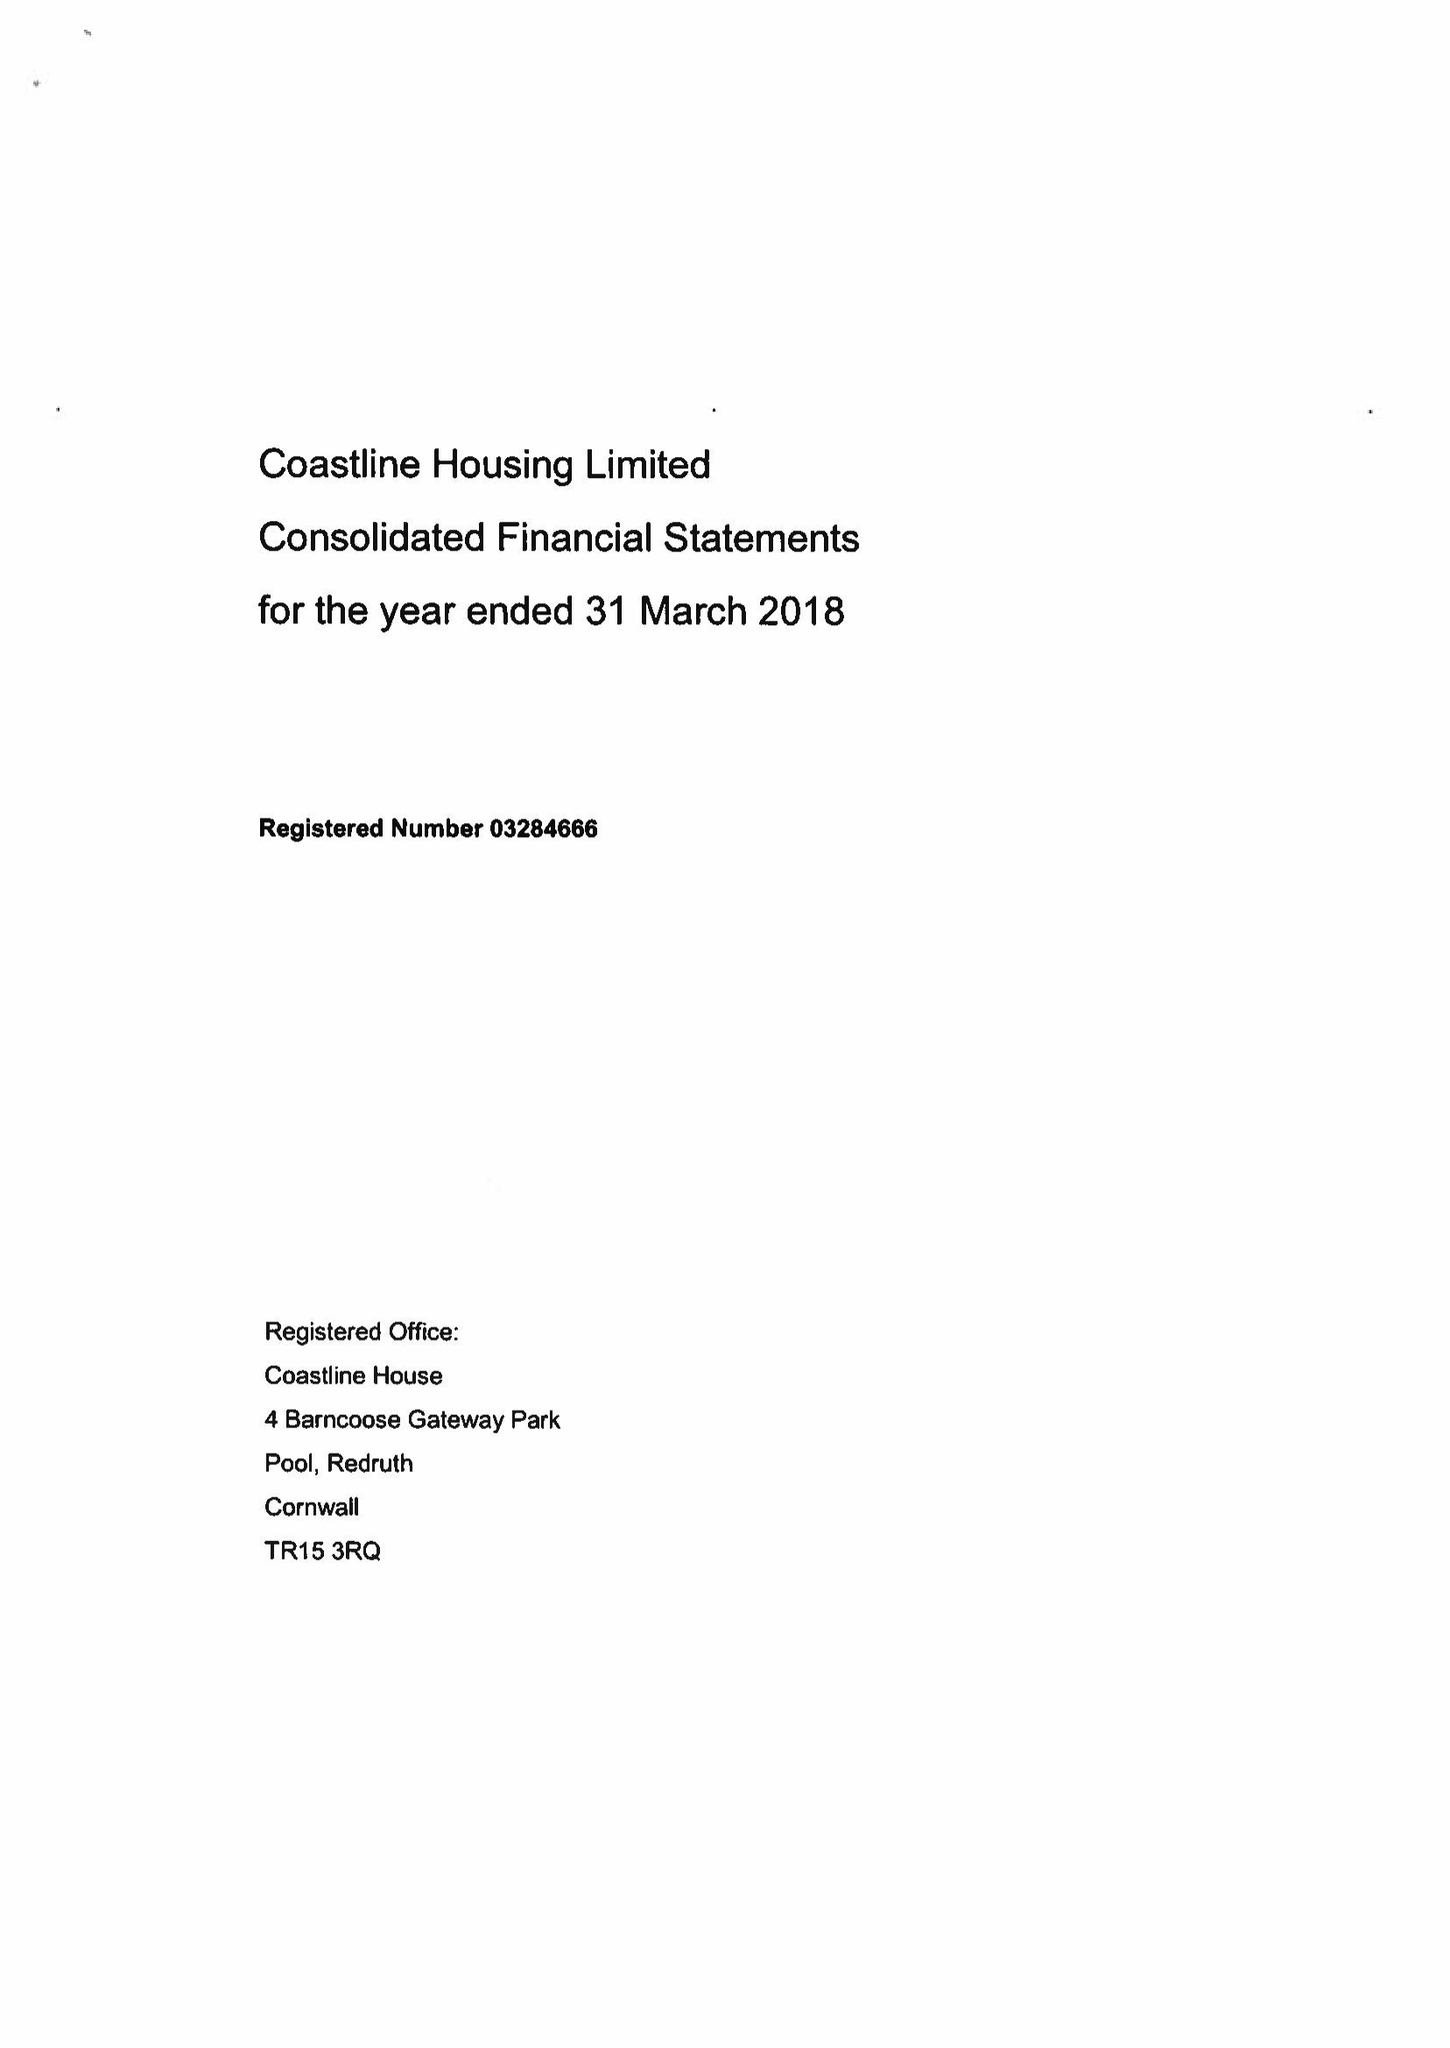What is the value for the charity_name?
Answer the question using a single word or phrase. Coastline Housing Ltd. 